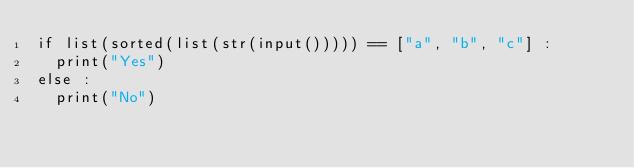Convert code to text. <code><loc_0><loc_0><loc_500><loc_500><_Python_>if list(sorted(list(str(input())))) == ["a", "b", "c"] :
  print("Yes")
else :
  print("No")</code> 